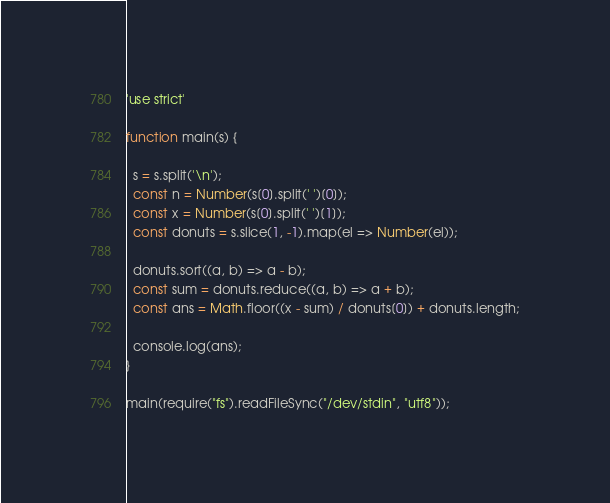<code> <loc_0><loc_0><loc_500><loc_500><_JavaScript_>'use strict'
 
function main(s) {
 
  s = s.split('\n');
  const n = Number(s[0].split(' ')[0]);
  const x = Number(s[0].split(' ')[1]);
  const donuts = s.slice(1, -1).map(el => Number(el));
 
  donuts.sort((a, b) => a - b);
  const sum = donuts.reduce((a, b) => a + b);
  const ans = Math.floor((x - sum) / donuts[0]) + donuts.length;
 
  console.log(ans);
}
 
main(require("fs").readFileSync("/dev/stdin", "utf8"));</code> 